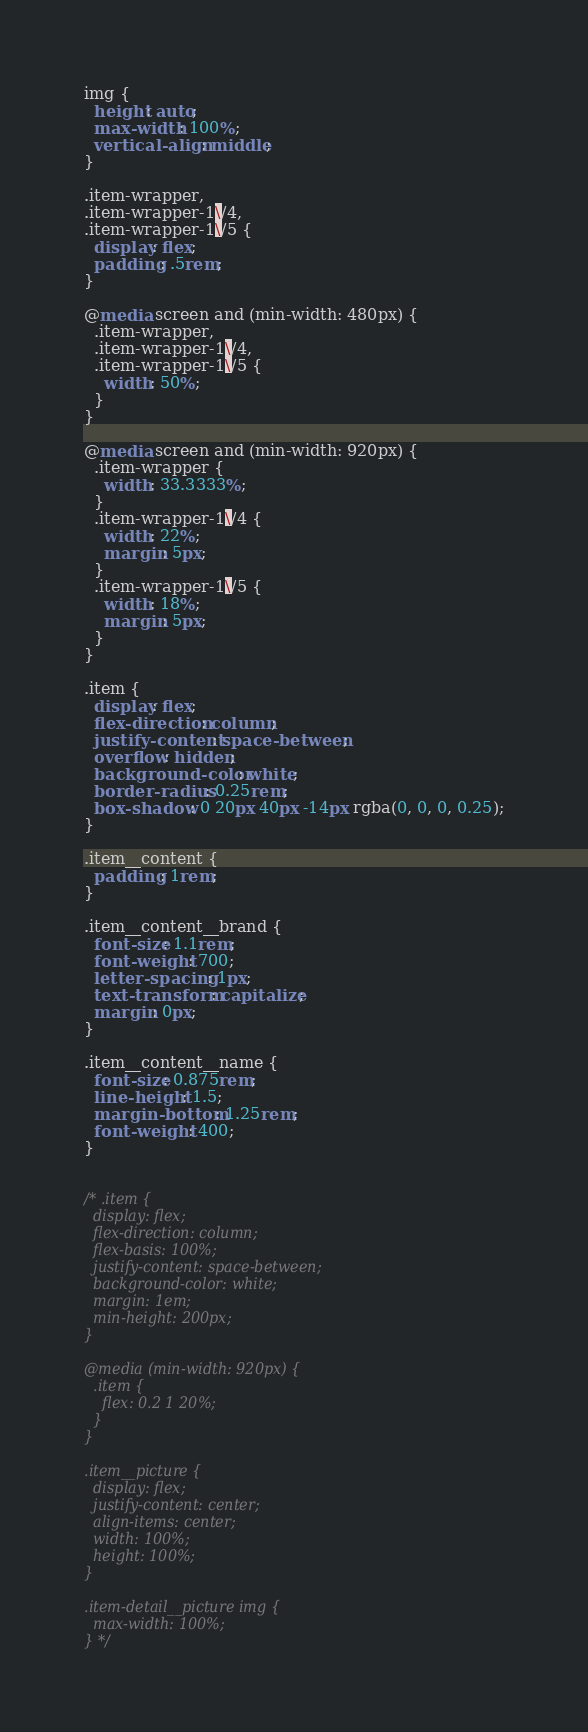Convert code to text. <code><loc_0><loc_0><loc_500><loc_500><_CSS_>
img {
  height: auto;
  max-width: 100%;
  vertical-align: middle;
}

.item-wrapper,
.item-wrapper-1\/4,
.item-wrapper-1\/5 {
  display: flex;
  padding: .5rem;
}

@media screen and (min-width: 480px) {
  .item-wrapper,
  .item-wrapper-1\/4,
  .item-wrapper-1\/5 {
    width: 50%;
  }
}

@media screen and (min-width: 920px) {
  .item-wrapper {
    width: 33.3333%;
  }
  .item-wrapper-1\/4 {
    width: 22%;
    margin: 5px;
  }
  .item-wrapper-1\/5 {
    width: 18%;
    margin: 5px;
  }
}

.item {
  display: flex;
  flex-direction: column;
  justify-content: space-between;
  overflow: hidden;
  background-color: white;
  border-radius: 0.25rem;
  box-shadow: 0 20px 40px -14px rgba(0, 0, 0, 0.25);
}

.item__content {
  padding: 1rem;
}

.item__content__brand {
  font-size: 1.1rem;
  font-weight: 700;
  letter-spacing: 1px;
  text-transform: capitalize;
  margin: 0px;
}

.item__content__name {
  font-size: 0.875rem;
  line-height: 1.5;
  margin-bottom: 1.25rem;
  font-weight: 400;
}


/* .item {
  display: flex;
  flex-direction: column;
  flex-basis: 100%;
  justify-content: space-between;
  background-color: white;
  margin: 1em;
  min-height: 200px;
}

@media (min-width: 920px) {
  .item {
    flex: 0.2 1 20%;
  }
}

.item__picture {
  display: flex;
  justify-content: center;
  align-items: center;
  width: 100%;
  height: 100%;
}

.item-detail__picture img {
  max-width: 100%;
} */
</code> 